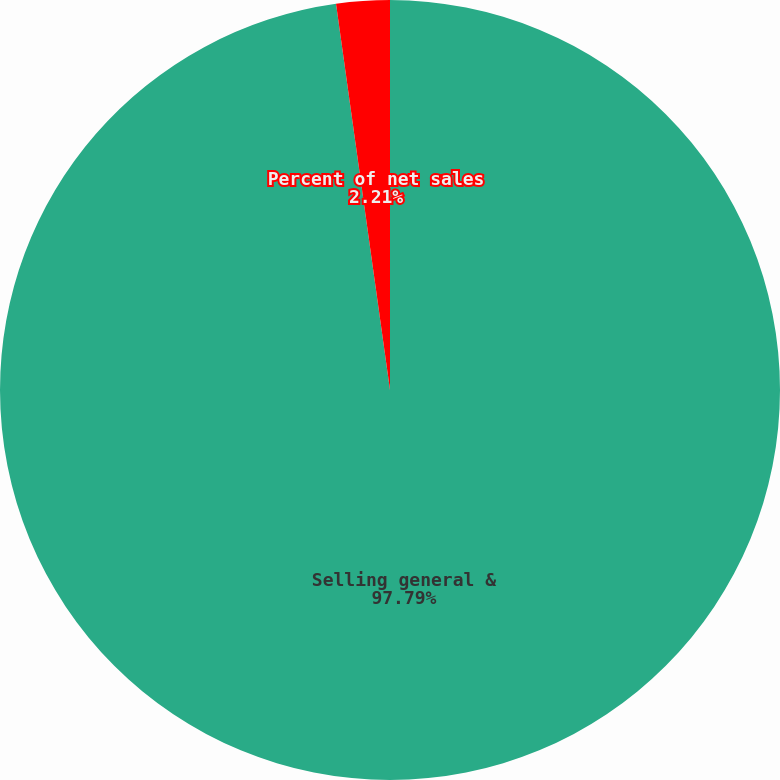Convert chart. <chart><loc_0><loc_0><loc_500><loc_500><pie_chart><fcel>Selling general &<fcel>Percent of net sales<nl><fcel>97.79%<fcel>2.21%<nl></chart> 